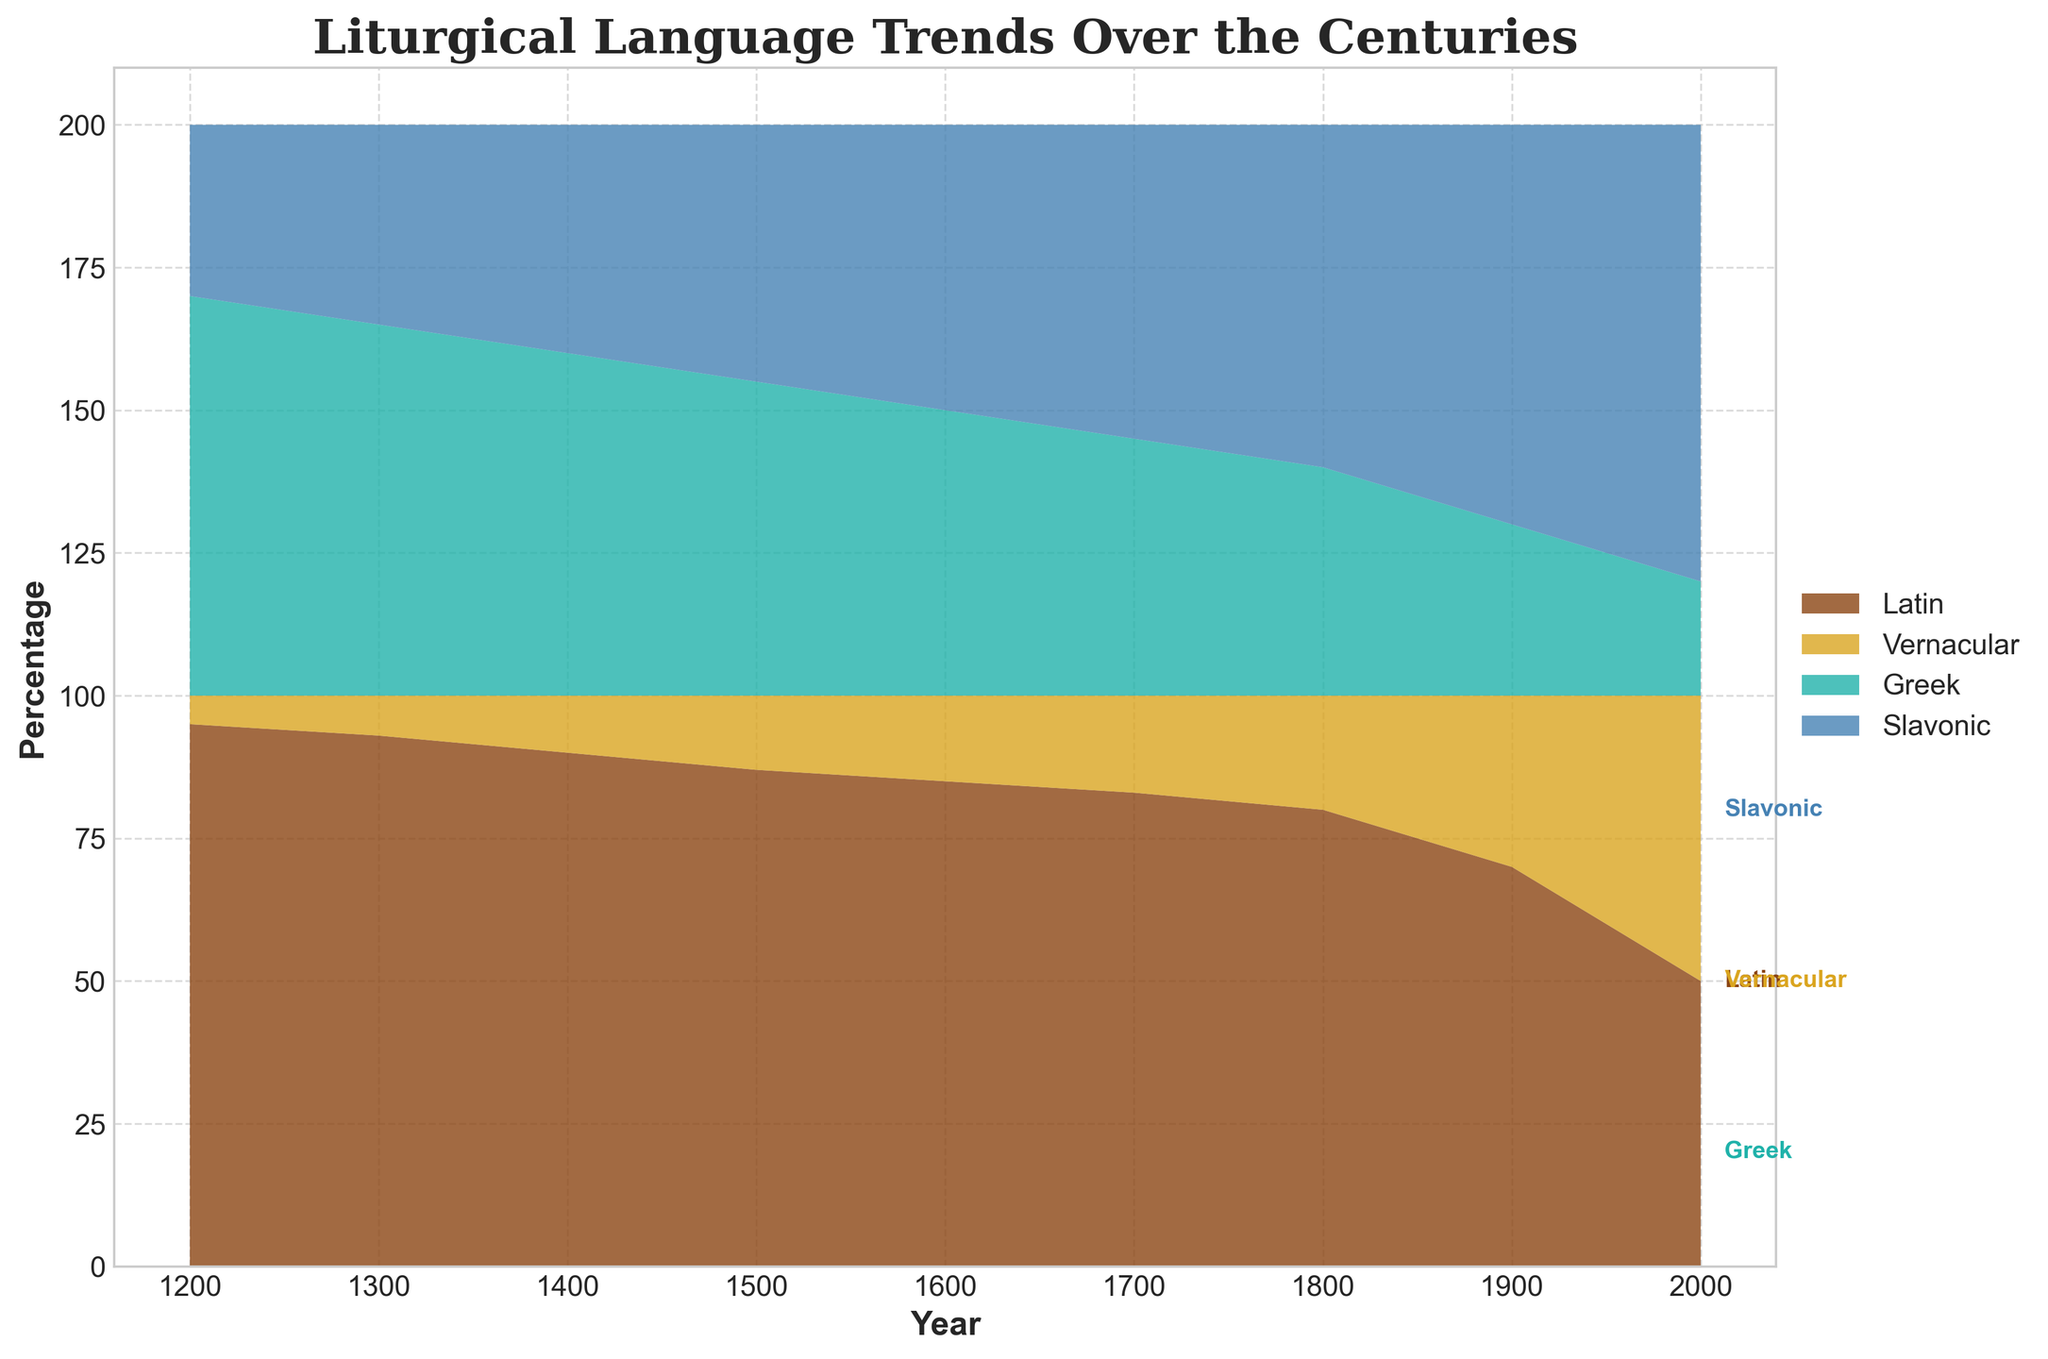What is the title of the figure? The title of the figure is displayed prominently at the top. It reads "Liturgical Language Trends Over the Centuries."
Answer: Liturgical Language Trends Over the Centuries Which language had a 95% share in Western Europe in 1200? By observing the figure, the label for 1200 on the x-axis and the corresponding stacked segment at 95% reveals that Latin had a 95% share in Western Europe in 1200.
Answer: Latin What is the trend for Vernacular languages in Western Europe from 1200 to 2000? By following the progression of the Vernacular section in the stream graph from left to right, we see that the share of Vernacular languages in Western Europe increases steadily over the centuries, from 5% in 1200 to 50% in 2000.
Answer: Increasing How did the percentage of Latin change in Western Europe between 1200 and 2000? By comparing the segment for Latin in Western Europe at 1200 and 2000, the percentage decreases from 95% in 1200 to 50% in 2000.
Answer: Decreased Which language had the largest increase in Eastern Europe from 1900 to 2000? Focusing on the segments for 1900 and 2000 in Eastern Europe, one can observe that the Slavonic segment grew significantly from 70% to 80%, which is the largest increase among the languages in that region.
Answer: Slavonic Between which years did Greek and Slavonic reach an equal percentage in Eastern Europe? Observing the figure, it can be noted that Greek and Slavonic had equal shares in Eastern Europe (each 50%) in the year 1600.
Answer: 1600 When did Latin start to decline more sharply in Western Europe? The figure shows that the decline of Latin in Western Europe becomes steeper after 1800, as the graph for Latin starts to drop more noticeably.
Answer: After 1800 What percentage of the liturgical language in Eastern Europe was Slavonic in 1700? By locating the segment at 1700 in Eastern Europe and noting the percentage marked, Slavonic held 55% of the liturgical language share in 1700.
Answer: 55% How does the percentage of Greek in Eastern Europe in 2000 compare to 1200? Comparing the segments for Greek in Eastern Europe in 2000 (20%) and 1200 (70%), it is evident that Greek's share has significantly decreased.
Answer: Decreased What is the combined percentage of non-Latin languages in Western Europe in 1600? Summing up the Vernacular percentage (15%) in Western Europe in 1600, we get a combined non-Latin language percentage of 15%.
Answer: 15% 